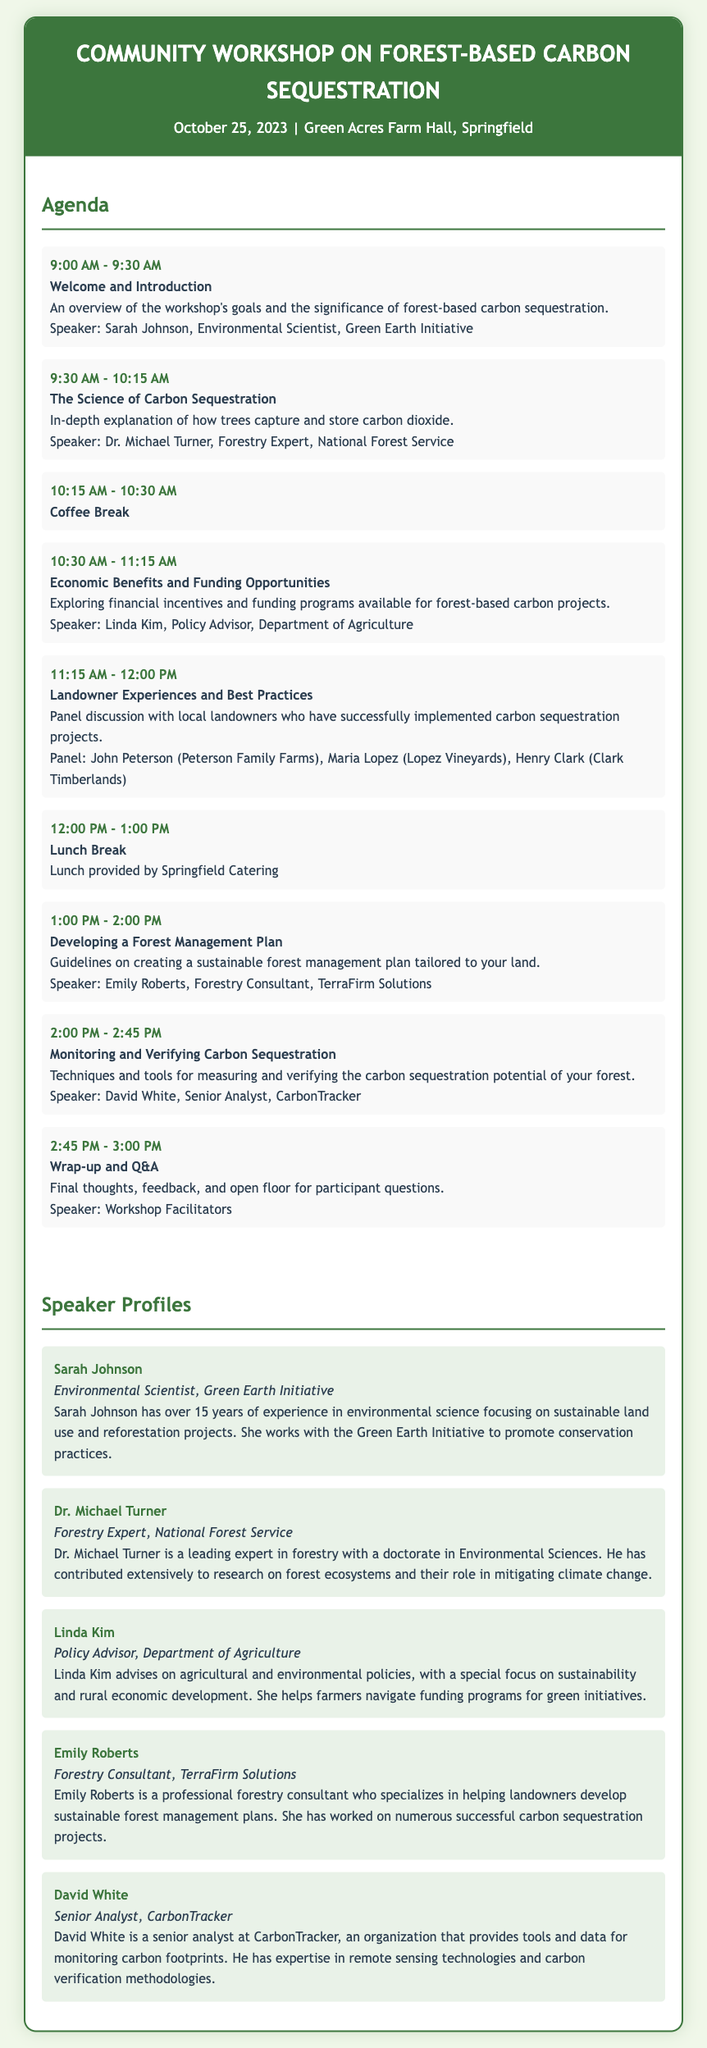What is the date of the workshop? The workshop is scheduled for October 25, 2023, as stated in the header section of the document.
Answer: October 25, 2023 Who is the speaker for the "The Science of Carbon Sequestration"? The document lists Dr. Michael Turner as the speaker for this event.
Answer: Dr. Michael Turner What time does the "Lunch Break" start? The document indicates that the "Lunch Break" is from 12:00 PM to 1:00 PM, which is stated in the agenda section.
Answer: 12:00 PM What is the main topic of Emily Roberts' presentation? Emily Roberts will present on "Developing a Forest Management Plan," as noted in her agenda item.
Answer: Developing a Forest Management Plan How many speakers are listed in the speaker profiles? There are five distinct speakers profiled in the document.
Answer: Five What are the landowner experiences focused on during the workshop? The agenda specifies that they will discuss "Landowner Experiences and Best Practices".
Answer: Experiences and Best Practices Who facilitates the final Q&A session? The document notes that the final Q&A will be facilitated by the workshop facilitators.
Answer: Workshop Facilitators What organization is Linda Kim associated with? According to the document, Linda Kim is a Policy Advisor at the Department of Agriculture.
Answer: Department of Agriculture 